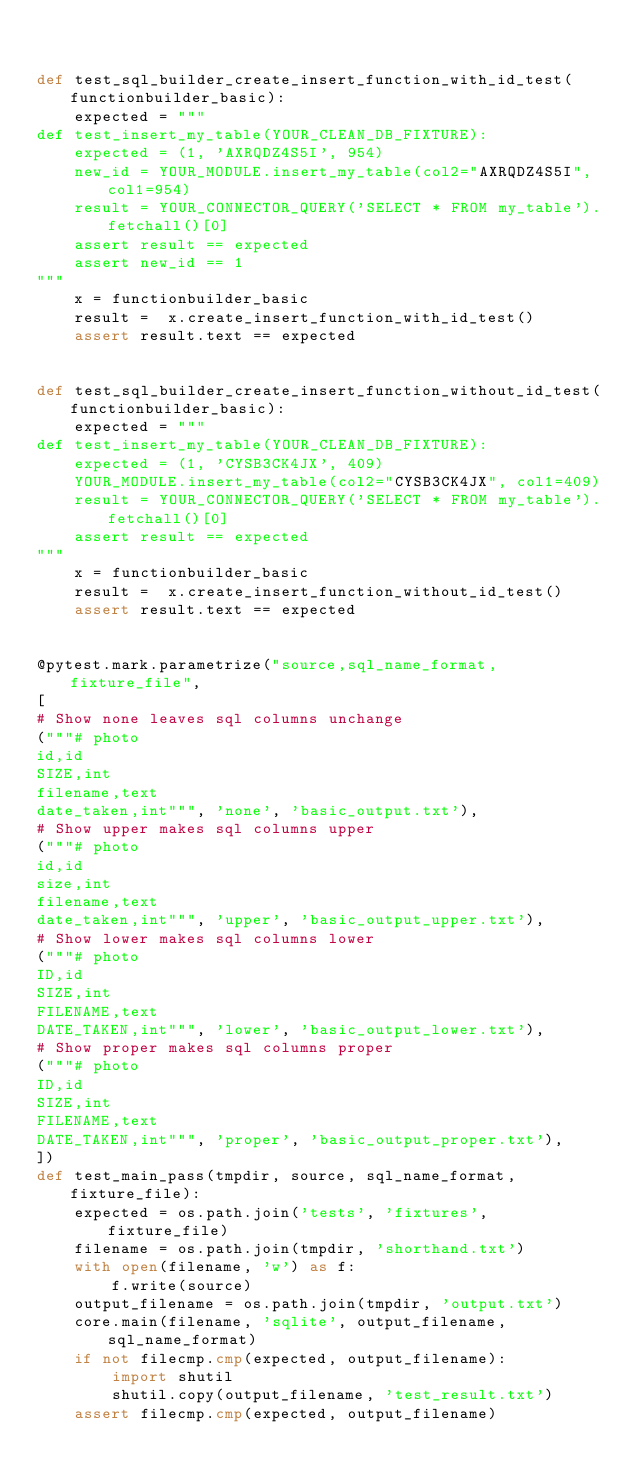<code> <loc_0><loc_0><loc_500><loc_500><_Python_>

def test_sql_builder_create_insert_function_with_id_test(functionbuilder_basic):
    expected = """
def test_insert_my_table(YOUR_CLEAN_DB_FIXTURE):
    expected = (1, 'AXRQDZ4S5I', 954)
    new_id = YOUR_MODULE.insert_my_table(col2="AXRQDZ4S5I", col1=954)
    result = YOUR_CONNECTOR_QUERY('SELECT * FROM my_table').fetchall()[0]
    assert result == expected
    assert new_id == 1
"""
    x = functionbuilder_basic
    result =  x.create_insert_function_with_id_test()
    assert result.text == expected


def test_sql_builder_create_insert_function_without_id_test(functionbuilder_basic):
    expected = """
def test_insert_my_table(YOUR_CLEAN_DB_FIXTURE):
    expected = (1, 'CYSB3CK4JX', 409)
    YOUR_MODULE.insert_my_table(col2="CYSB3CK4JX", col1=409)
    result = YOUR_CONNECTOR_QUERY('SELECT * FROM my_table').fetchall()[0]
    assert result == expected
"""
    x = functionbuilder_basic
    result =  x.create_insert_function_without_id_test()
    assert result.text == expected


@pytest.mark.parametrize("source,sql_name_format,fixture_file",
[
# Show none leaves sql columns unchange
("""# photo
id,id
SIZE,int
filename,text
date_taken,int""", 'none', 'basic_output.txt'),
# Show upper makes sql columns upper
("""# photo
id,id
size,int
filename,text
date_taken,int""", 'upper', 'basic_output_upper.txt'),
# Show lower makes sql columns lower
("""# photo
ID,id
SIZE,int
FILENAME,text
DATE_TAKEN,int""", 'lower', 'basic_output_lower.txt'),
# Show proper makes sql columns proper
("""# photo
ID,id
SIZE,int
FILENAME,text
DATE_TAKEN,int""", 'proper', 'basic_output_proper.txt'),
])
def test_main_pass(tmpdir, source, sql_name_format, fixture_file):
    expected = os.path.join('tests', 'fixtures', fixture_file)
    filename = os.path.join(tmpdir, 'shorthand.txt')
    with open(filename, 'w') as f:
        f.write(source)
    output_filename = os.path.join(tmpdir, 'output.txt')
    core.main(filename, 'sqlite', output_filename, sql_name_format)
    if not filecmp.cmp(expected, output_filename):
        import shutil
        shutil.copy(output_filename, 'test_result.txt')
    assert filecmp.cmp(expected, output_filename)
    
</code> 